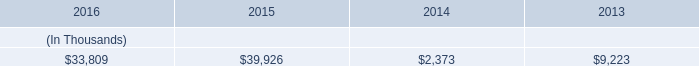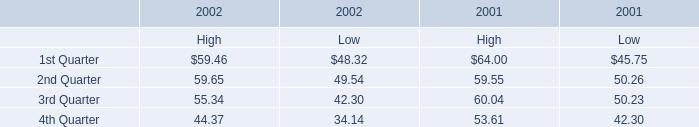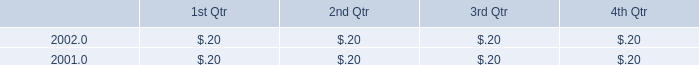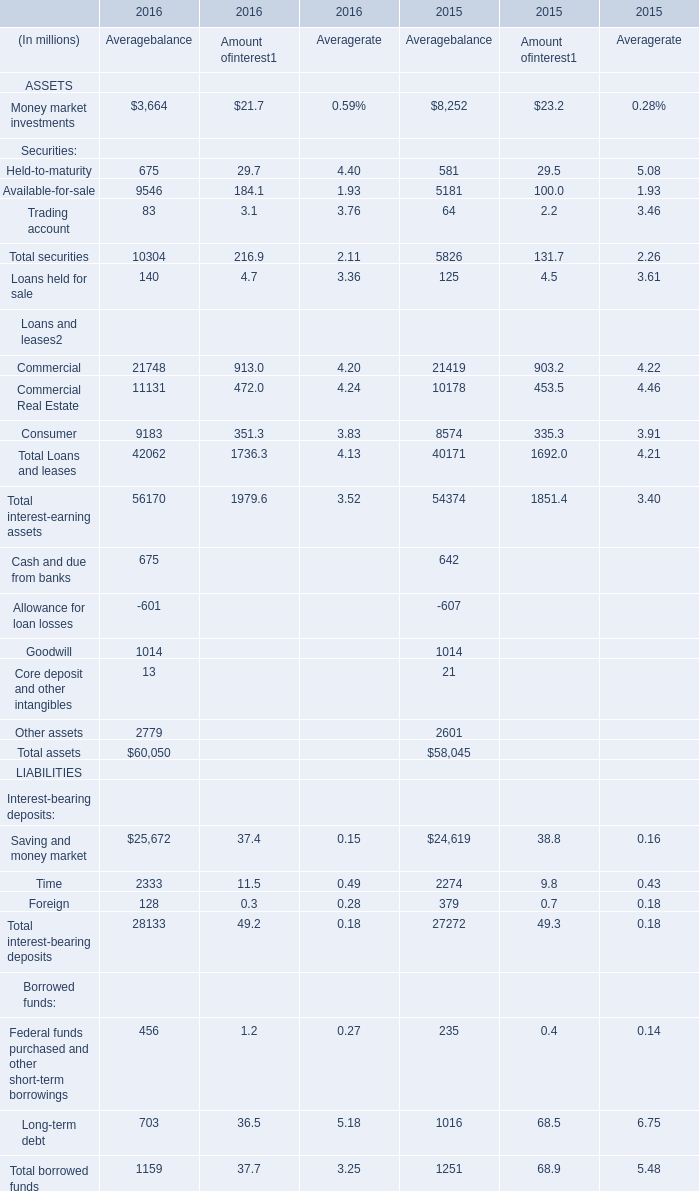as of december 31 , 2016 , what is the remaining capacity ( in millions ) for the credit facility scheduled to expire in may 2019? 
Computations: (120 - 66.9)
Answer: 53.1. 